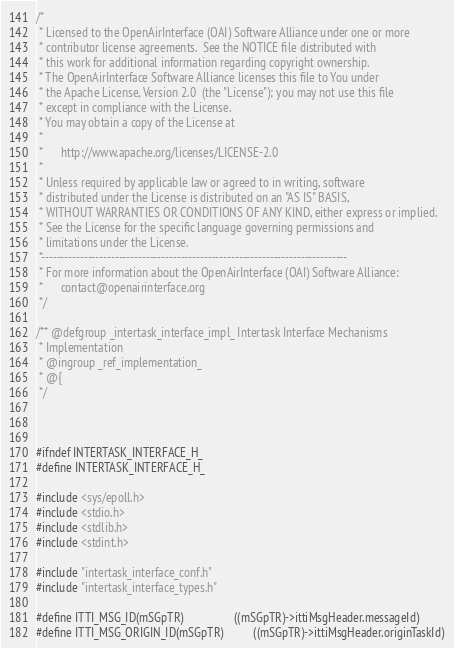Convert code to text. <code><loc_0><loc_0><loc_500><loc_500><_C_>/*
 * Licensed to the OpenAirInterface (OAI) Software Alliance under one or more
 * contributor license agreements.  See the NOTICE file distributed with
 * this work for additional information regarding copyright ownership.
 * The OpenAirInterface Software Alliance licenses this file to You under
 * the Apache License, Version 2.0  (the "License"); you may not use this file
 * except in compliance with the License.
 * You may obtain a copy of the License at
 *
 *      http://www.apache.org/licenses/LICENSE-2.0
 *
 * Unless required by applicable law or agreed to in writing, software
 * distributed under the License is distributed on an "AS IS" BASIS,
 * WITHOUT WARRANTIES OR CONDITIONS OF ANY KIND, either express or implied.
 * See the License for the specific language governing permissions and
 * limitations under the License.
 *-------------------------------------------------------------------------------
 * For more information about the OpenAirInterface (OAI) Software Alliance:
 *      contact@openairinterface.org
 */

/** @defgroup _intertask_interface_impl_ Intertask Interface Mechanisms
 * Implementation
 * @ingroup _ref_implementation_
 * @{
 */



#ifndef INTERTASK_INTERFACE_H_
#define INTERTASK_INTERFACE_H_

#include <sys/epoll.h>
#include <stdio.h>
#include <stdlib.h>
#include <stdint.h>

#include "intertask_interface_conf.h"
#include "intertask_interface_types.h"

#define ITTI_MSG_ID(mSGpTR)                 ((mSGpTR)->ittiMsgHeader.messageId)
#define ITTI_MSG_ORIGIN_ID(mSGpTR)          ((mSGpTR)->ittiMsgHeader.originTaskId)</code> 